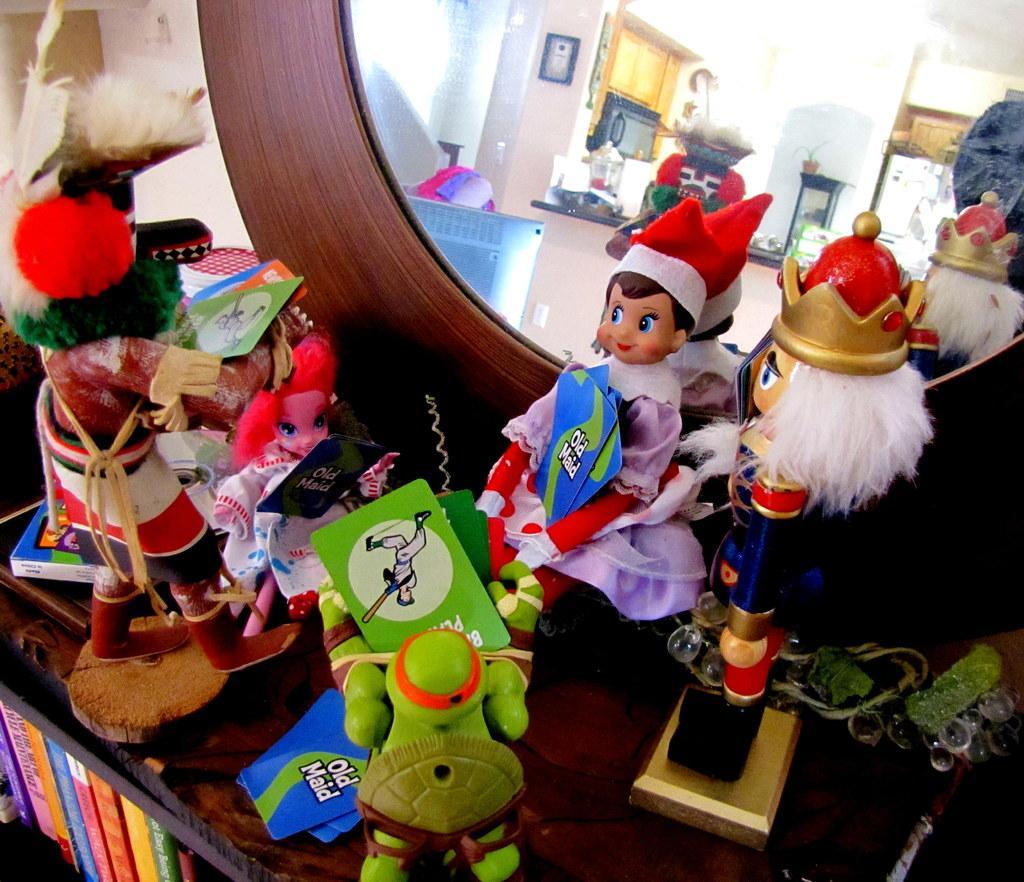Could you give a brief overview of what you see in this image? In this picture we can see a mirror stand on which we can see so many toys are placed and also we can see some books. 